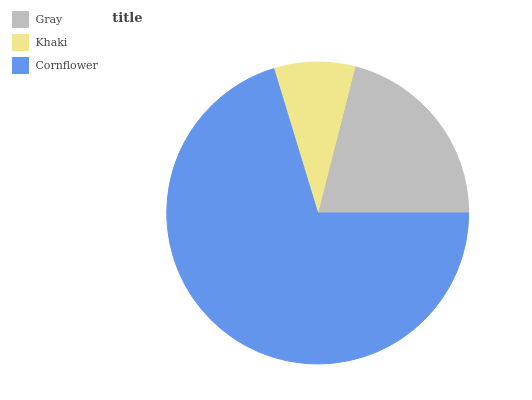Is Khaki the minimum?
Answer yes or no. Yes. Is Cornflower the maximum?
Answer yes or no. Yes. Is Cornflower the minimum?
Answer yes or no. No. Is Khaki the maximum?
Answer yes or no. No. Is Cornflower greater than Khaki?
Answer yes or no. Yes. Is Khaki less than Cornflower?
Answer yes or no. Yes. Is Khaki greater than Cornflower?
Answer yes or no. No. Is Cornflower less than Khaki?
Answer yes or no. No. Is Gray the high median?
Answer yes or no. Yes. Is Gray the low median?
Answer yes or no. Yes. Is Cornflower the high median?
Answer yes or no. No. Is Khaki the low median?
Answer yes or no. No. 